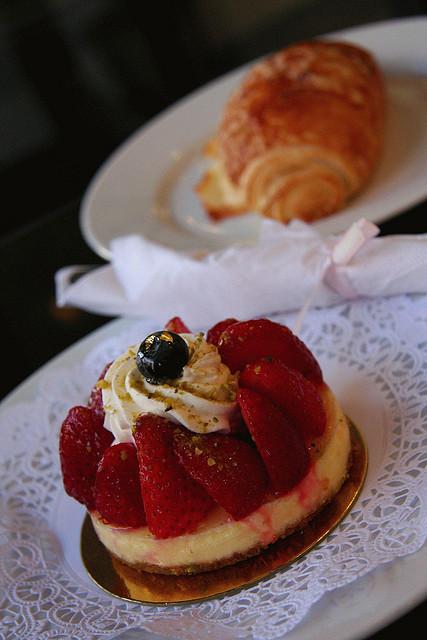How many desserts?
Give a very brief answer. 2. What types of berry is in the image?
Answer briefly. Strawberries. What dessert is in the foreground?
Give a very brief answer. Cheesecake. 